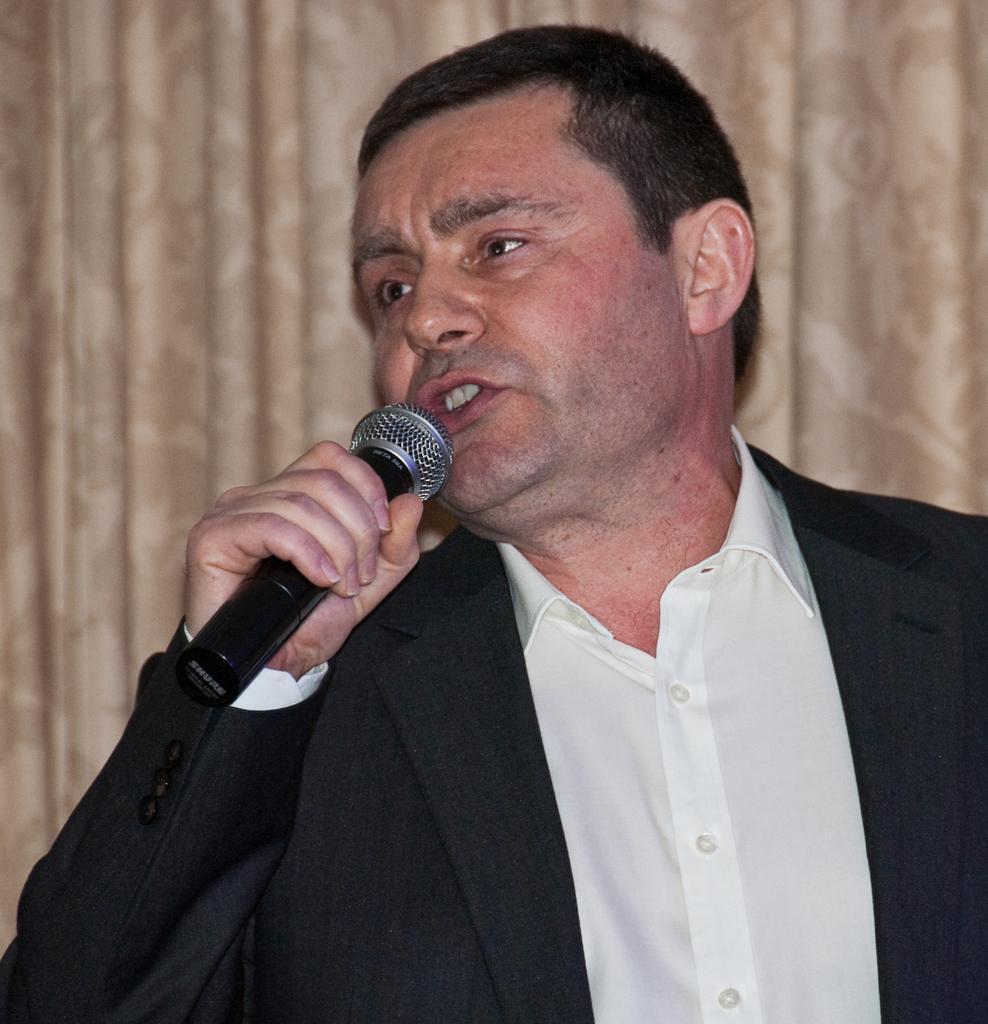Could you give a brief overview of what you see in this image? In this image, human wear a suit, shirt. He hold a microphone. He is taking. Background, we can see a cream color curtain. 